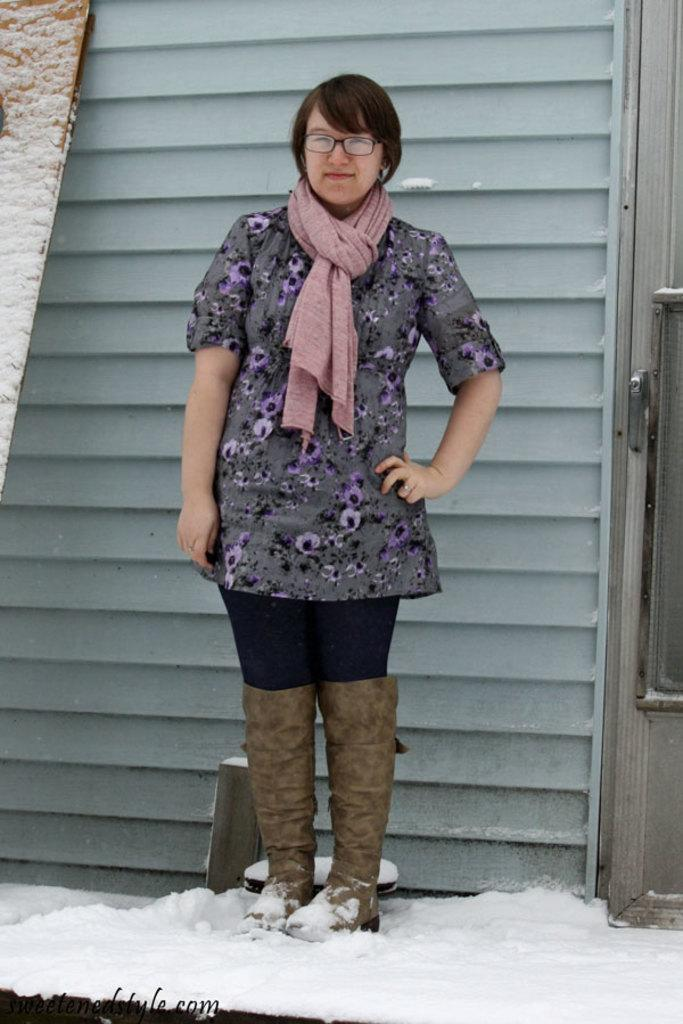Who is the main subject in the image? There is a lady in the image. What is the lady doing in the image? The lady is standing. What type of footwear is the lady wearing? The lady is wearing a snow boot. What accessory is the lady wearing on her face? The lady is wearing spectacles. Is the lady sleeping in the image? No, the lady is not sleeping in the image; she is standing. Who are the lady's friends in the image? There is no mention of friends in the image; it only features the lady. 